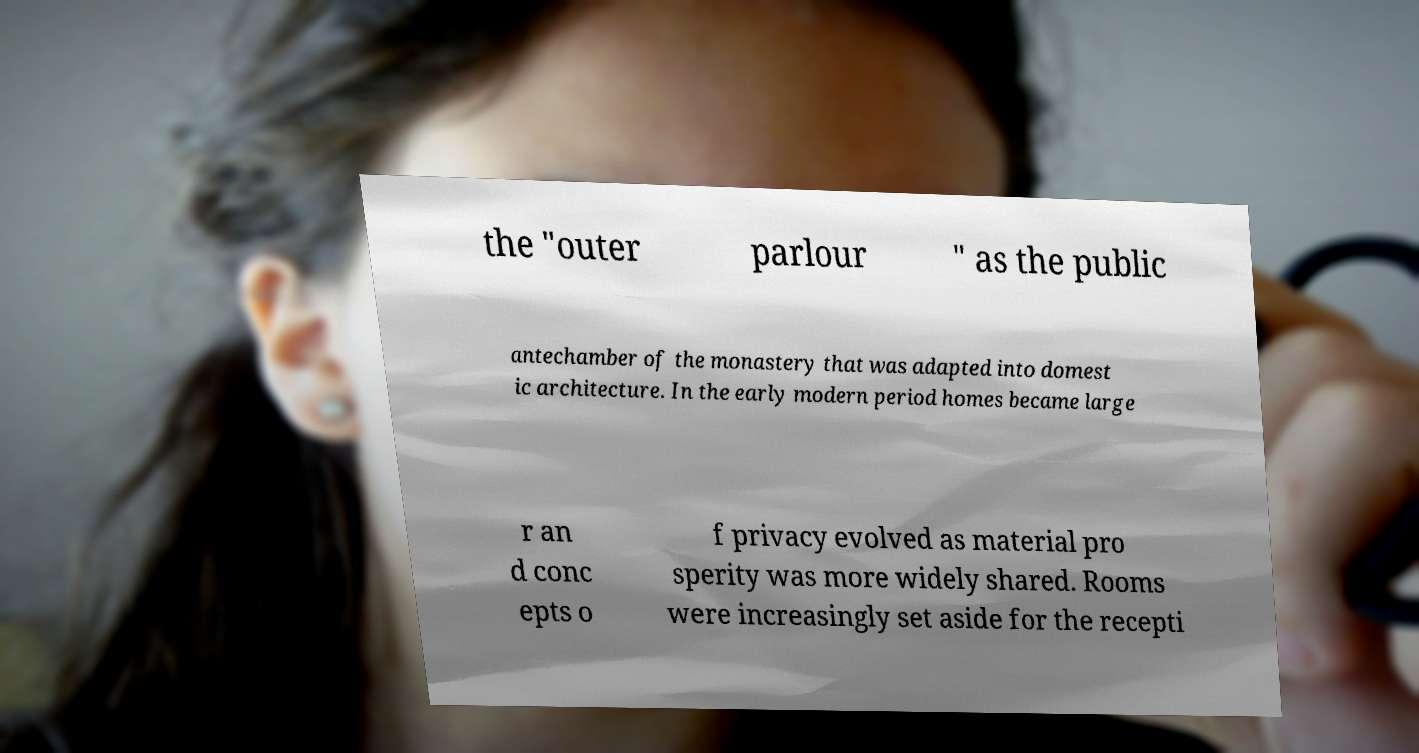Please read and relay the text visible in this image. What does it say? the "outer parlour " as the public antechamber of the monastery that was adapted into domest ic architecture. In the early modern period homes became large r an d conc epts o f privacy evolved as material pro sperity was more widely shared. Rooms were increasingly set aside for the recepti 